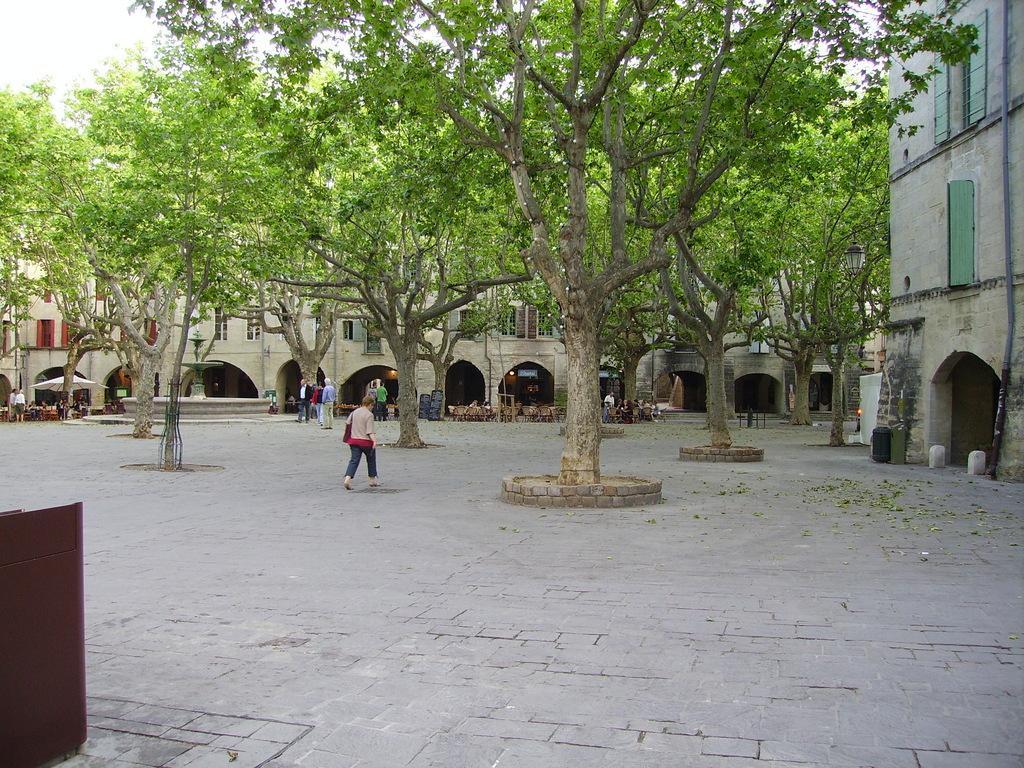In one or two sentences, can you explain what this image depicts? In this image in the front on the left side there is an object which is brown in colour. In the background there are trees, buildings and there are persons. 